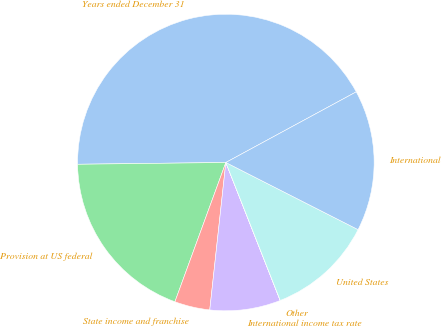<chart> <loc_0><loc_0><loc_500><loc_500><pie_chart><fcel>Years ended December 31<fcel>Provision at US federal<fcel>State income and franchise<fcel>International income tax rate<fcel>Other<fcel>United States<fcel>International<nl><fcel>42.29%<fcel>19.23%<fcel>3.85%<fcel>7.7%<fcel>0.01%<fcel>11.54%<fcel>15.38%<nl></chart> 